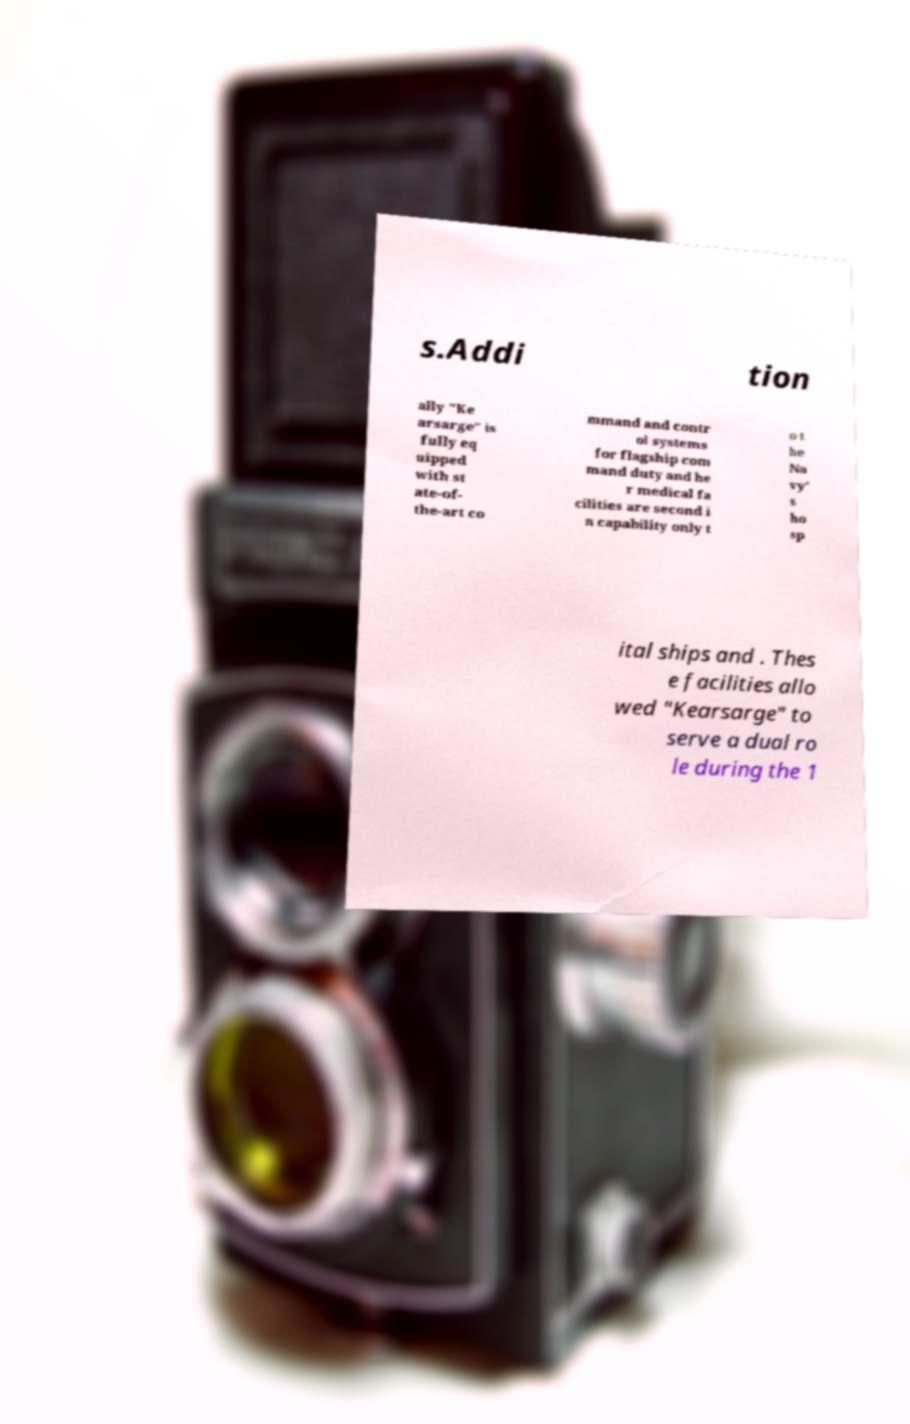Please read and relay the text visible in this image. What does it say? s.Addi tion ally "Ke arsarge" is fully eq uipped with st ate-of- the-art co mmand and contr ol systems for flagship com mand duty and he r medical fa cilities are second i n capability only t o t he Na vy' s ho sp ital ships and . Thes e facilities allo wed "Kearsarge" to serve a dual ro le during the 1 